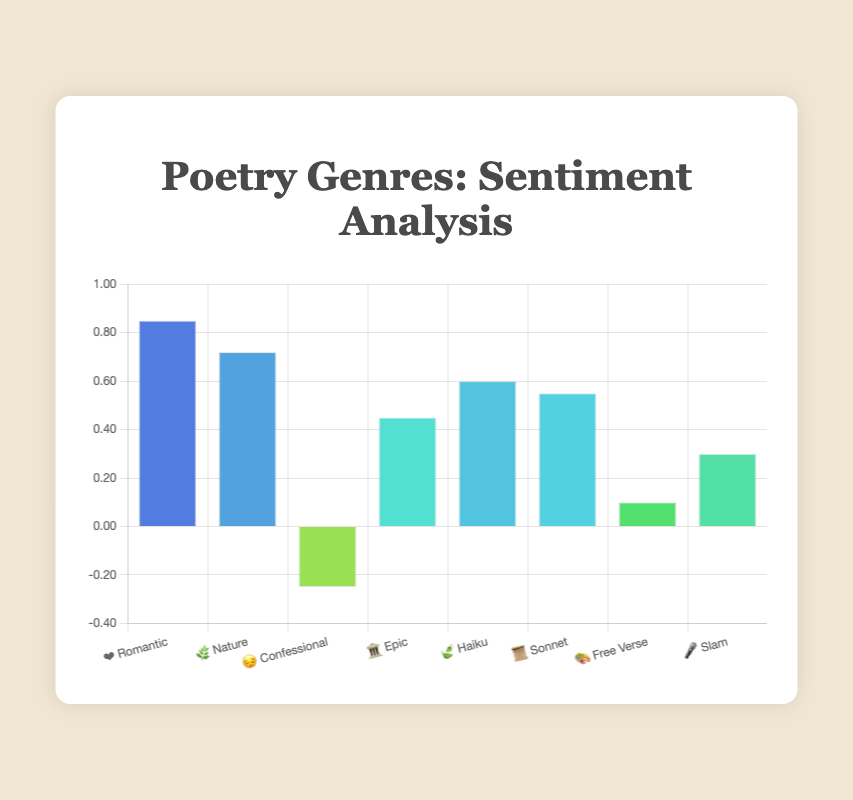What does the highest sentiment score represent visually? The highest sentiment score is represented by the Romantic genre, indicated with the heart emoji (❤️), which shows the sentiment score at approximately 0.85.
Answer: Romantic (❤️) Which genre has the lowest sentiment score and what emoji represents it? The genre with the lowest sentiment score is the Confessional genre, represented by the sad face emoji (😔), with a negative sentiment score of -0.25.
Answer: Confessional (😔) How many genres have a sentiment score above 0.5? To find the number of genres with a sentiment score above 0.5, observe the bars that extend beyond the 0.5 mark on the Y-axis. These genres are Romantic, Nature, Haiku, and Sonnet, totaling 4 genres.
Answer: 4 What is the combined sentiment score of the Nature and Haiku genres? To calculate the combined sentiment score of Nature and Haiku, add their sentiment scores: Nature (0.72) + Haiku (0.60) = 1.32.
Answer: 1.32 How does the sentiment score of Free Verse compare to Slam? Comparing the sentiment scores of Free Verse (0.10) and Slam (0.30), Free Verse has a lower sentiment score than Slam.
Answer: Slam (🎤) > Free Verse (🎨) What range of colors do the bars represent? The bar colors range between hues of green-yellow to green, depending on the sentiment scores. Higher sentiment scores are more greenish, resulting from hue values calculated based on the sentiment scores, with greener shades indicating higher sentiment.
Answer: Green-yellow to green Which genre sits closest to the middle in terms of sentiment score? To find the genre closest to the middle sentiment score, we calculate the median sentiment score of all genres: (0.85, 0.72, -0.25, 0.45, 0.60, 0.55, 0.10, 0.30). The median is (0.45 + 0.55)/2 = 0.50. The genre closest to this value is Slam with a score of 0.30.
Answer: Slam (🎤) Are there any genres with sentiment scores lower than 0? Yes, the Confessional genre has a sentiment score lower than 0, specifically -0.25.
Answer: Yes (😔) Is there any genre whose sentiment score is exactly the same as another? No genres have the exact same sentiment score. Each genre has a unique sentiment score ranging from -0.25 to 0.85.
Answer: No 